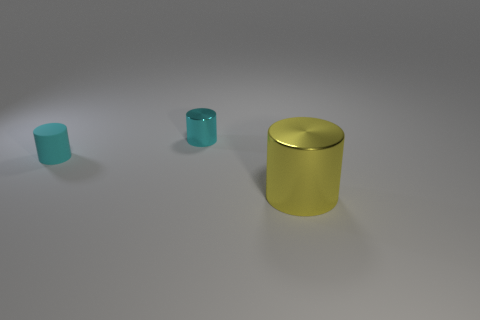What color is the other cylinder that is made of the same material as the yellow cylinder?
Offer a very short reply. Cyan. Are there fewer big yellow things that are in front of the big yellow metallic thing than cyan objects on the right side of the tiny cyan rubber thing?
Keep it short and to the point. Yes. How many shiny objects are the same color as the small matte cylinder?
Your answer should be very brief. 1. What is the material of the other cylinder that is the same color as the small metallic cylinder?
Provide a short and direct response. Rubber. What number of things are to the right of the cyan matte cylinder and left of the big yellow cylinder?
Offer a very short reply. 1. What is the material of the small cylinder in front of the shiny object behind the big object?
Ensure brevity in your answer.  Rubber. Is there a tiny cyan object that has the same material as the big yellow object?
Your answer should be compact. Yes. There is a cyan thing that is the same size as the matte cylinder; what is its material?
Provide a short and direct response. Metal. How big is the cyan object behind the small cylinder that is left of the metal cylinder that is to the left of the yellow thing?
Ensure brevity in your answer.  Small. There is a small cylinder behind the matte object; is there a small metal object on the left side of it?
Provide a succinct answer. No. 